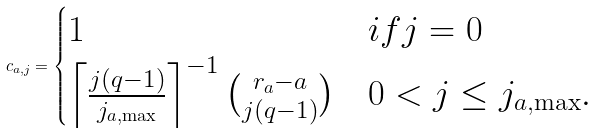<formula> <loc_0><loc_0><loc_500><loc_500>c _ { a , j } = \begin{cases} 1 & i f j = 0 \\ \left \lceil \frac { j ( q - 1 ) } { j _ { a , \max } } \right \rceil ^ { - 1 } \binom { r _ { a } - a } { j ( q - 1 ) } & 0 < j \leq j _ { a , \max } . \end{cases}</formula> 